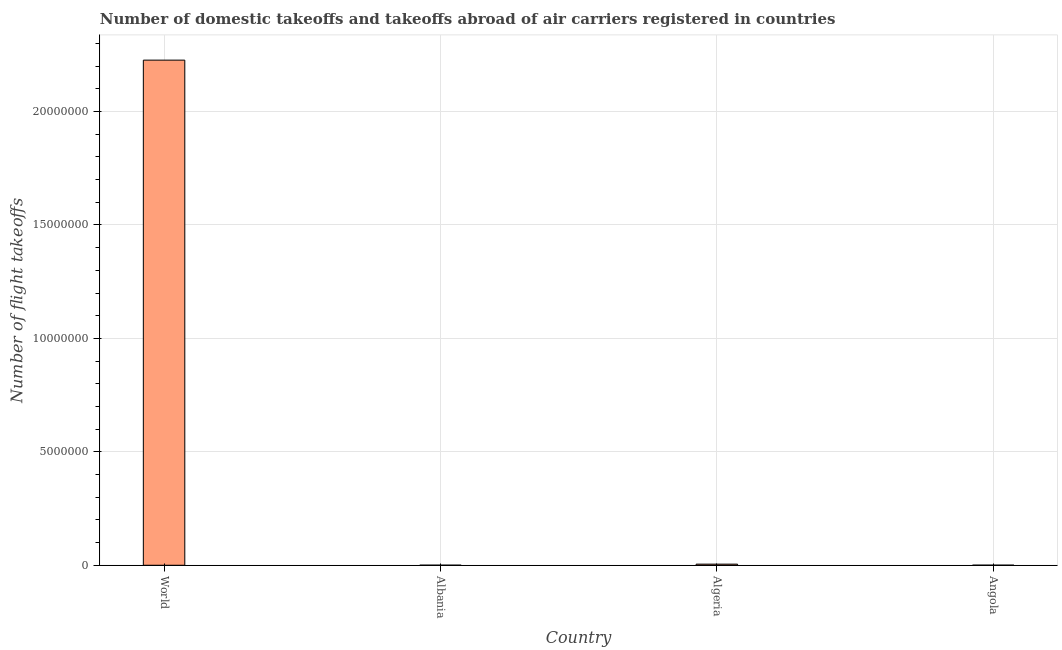Does the graph contain any zero values?
Offer a very short reply. No. Does the graph contain grids?
Keep it short and to the point. Yes. What is the title of the graph?
Make the answer very short. Number of domestic takeoffs and takeoffs abroad of air carriers registered in countries. What is the label or title of the Y-axis?
Your answer should be compact. Number of flight takeoffs. What is the number of flight takeoffs in Angola?
Ensure brevity in your answer.  4354. Across all countries, what is the maximum number of flight takeoffs?
Give a very brief answer. 2.23e+07. Across all countries, what is the minimum number of flight takeoffs?
Ensure brevity in your answer.  3974. In which country was the number of flight takeoffs minimum?
Your answer should be compact. Albania. What is the sum of the number of flight takeoffs?
Your response must be concise. 2.23e+07. What is the difference between the number of flight takeoffs in Angola and World?
Ensure brevity in your answer.  -2.23e+07. What is the average number of flight takeoffs per country?
Provide a succinct answer. 5.58e+06. What is the median number of flight takeoffs?
Provide a succinct answer. 2.68e+04. In how many countries, is the number of flight takeoffs greater than 17000000 ?
Make the answer very short. 1. What is the ratio of the number of flight takeoffs in Algeria to that in Angola?
Offer a very short reply. 11.32. Is the number of flight takeoffs in Albania less than that in Algeria?
Offer a very short reply. Yes. What is the difference between the highest and the second highest number of flight takeoffs?
Give a very brief answer. 2.22e+07. Is the sum of the number of flight takeoffs in Albania and Angola greater than the maximum number of flight takeoffs across all countries?
Your response must be concise. No. What is the difference between the highest and the lowest number of flight takeoffs?
Offer a very short reply. 2.23e+07. In how many countries, is the number of flight takeoffs greater than the average number of flight takeoffs taken over all countries?
Ensure brevity in your answer.  1. How many bars are there?
Ensure brevity in your answer.  4. How many countries are there in the graph?
Ensure brevity in your answer.  4. What is the difference between two consecutive major ticks on the Y-axis?
Your answer should be very brief. 5.00e+06. Are the values on the major ticks of Y-axis written in scientific E-notation?
Offer a very short reply. No. What is the Number of flight takeoffs of World?
Provide a short and direct response. 2.23e+07. What is the Number of flight takeoffs in Albania?
Your answer should be compact. 3974. What is the Number of flight takeoffs in Algeria?
Make the answer very short. 4.93e+04. What is the Number of flight takeoffs of Angola?
Offer a terse response. 4354. What is the difference between the Number of flight takeoffs in World and Albania?
Your answer should be compact. 2.23e+07. What is the difference between the Number of flight takeoffs in World and Algeria?
Keep it short and to the point. 2.22e+07. What is the difference between the Number of flight takeoffs in World and Angola?
Offer a very short reply. 2.23e+07. What is the difference between the Number of flight takeoffs in Albania and Algeria?
Make the answer very short. -4.53e+04. What is the difference between the Number of flight takeoffs in Albania and Angola?
Make the answer very short. -380. What is the difference between the Number of flight takeoffs in Algeria and Angola?
Make the answer very short. 4.49e+04. What is the ratio of the Number of flight takeoffs in World to that in Albania?
Ensure brevity in your answer.  5602.47. What is the ratio of the Number of flight takeoffs in World to that in Algeria?
Keep it short and to the point. 451.85. What is the ratio of the Number of flight takeoffs in World to that in Angola?
Provide a succinct answer. 5113.51. What is the ratio of the Number of flight takeoffs in Albania to that in Algeria?
Your response must be concise. 0.08. What is the ratio of the Number of flight takeoffs in Albania to that in Angola?
Ensure brevity in your answer.  0.91. What is the ratio of the Number of flight takeoffs in Algeria to that in Angola?
Offer a terse response. 11.32. 